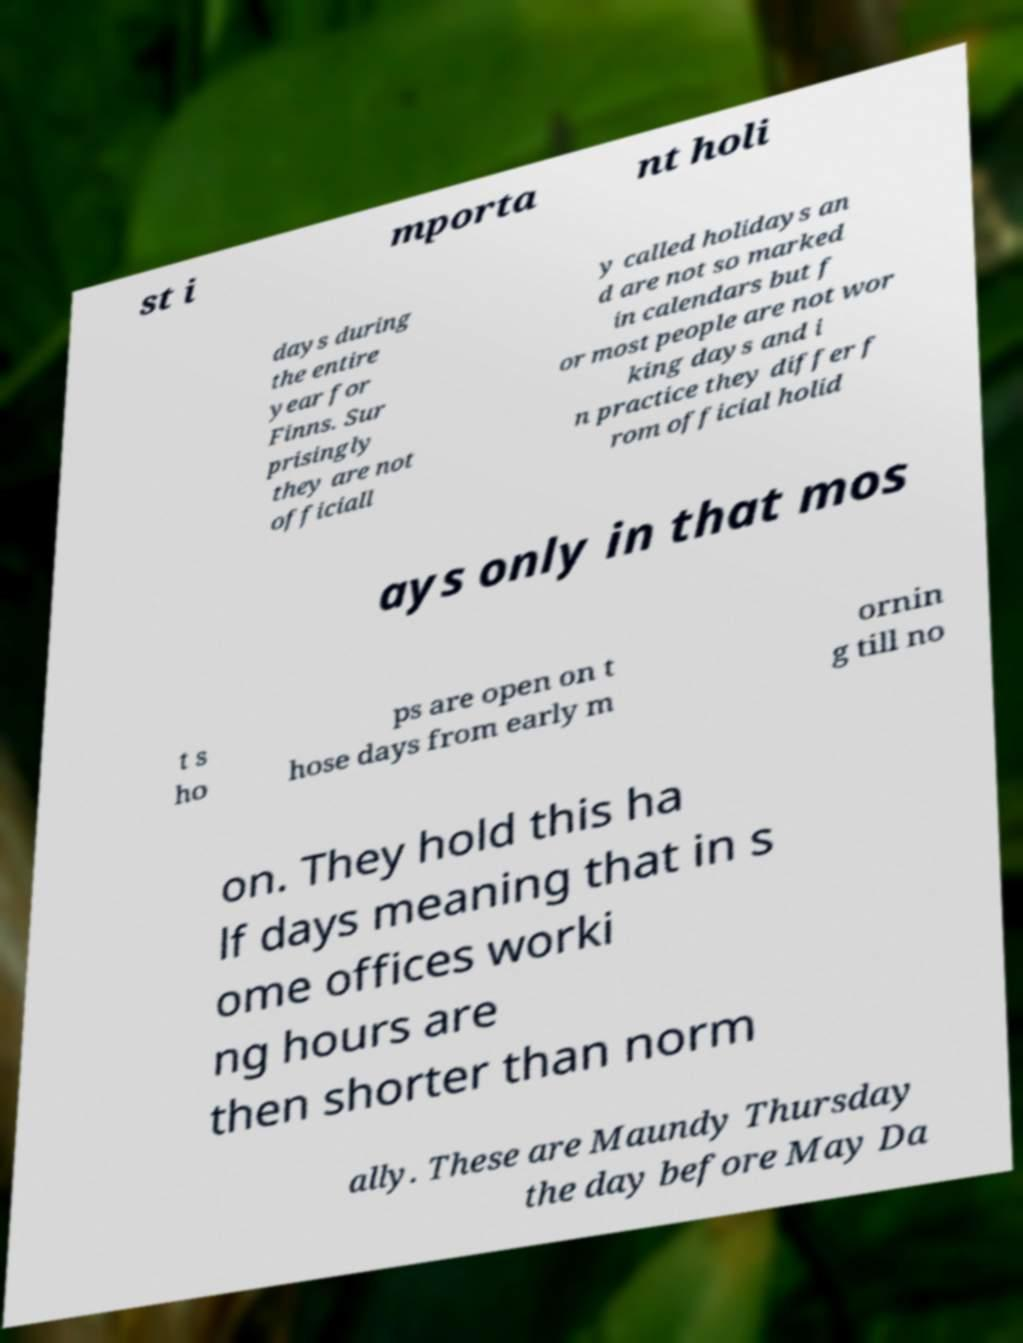Please identify and transcribe the text found in this image. st i mporta nt holi days during the entire year for Finns. Sur prisingly they are not officiall y called holidays an d are not so marked in calendars but f or most people are not wor king days and i n practice they differ f rom official holid ays only in that mos t s ho ps are open on t hose days from early m ornin g till no on. They hold this ha lf days meaning that in s ome offices worki ng hours are then shorter than norm ally. These are Maundy Thursday the day before May Da 